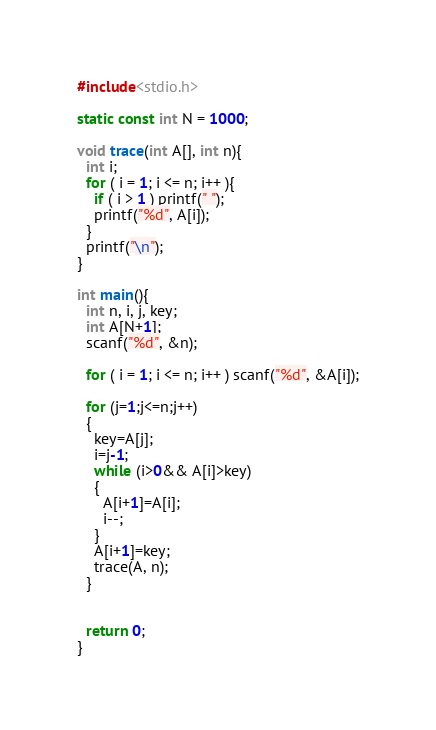Convert code to text. <code><loc_0><loc_0><loc_500><loc_500><_C_>#include<stdio.h>

static const int N = 1000;

void trace(int A[], int n){
  int i;
  for ( i = 1; i <= n; i++ ){
    if ( i > 1 ) printf(" ");
    printf("%d", A[i]);
  }
  printf("\n");
}

int main(){
  int n, i, j, key;
  int A[N+1];
  scanf("%d", &n);

  for ( i = 1; i <= n; i++ ) scanf("%d", &A[i]);
  
  for (j=1;j<=n;j++)
  {
    key=A[j];
    i=j-1;
    while (i>0&& A[i]>key)
    {
      A[i+1]=A[i];
      i--;
    }
    A[i+1]=key;
    trace(A, n);
  }
  
  
  return 0;
}</code> 